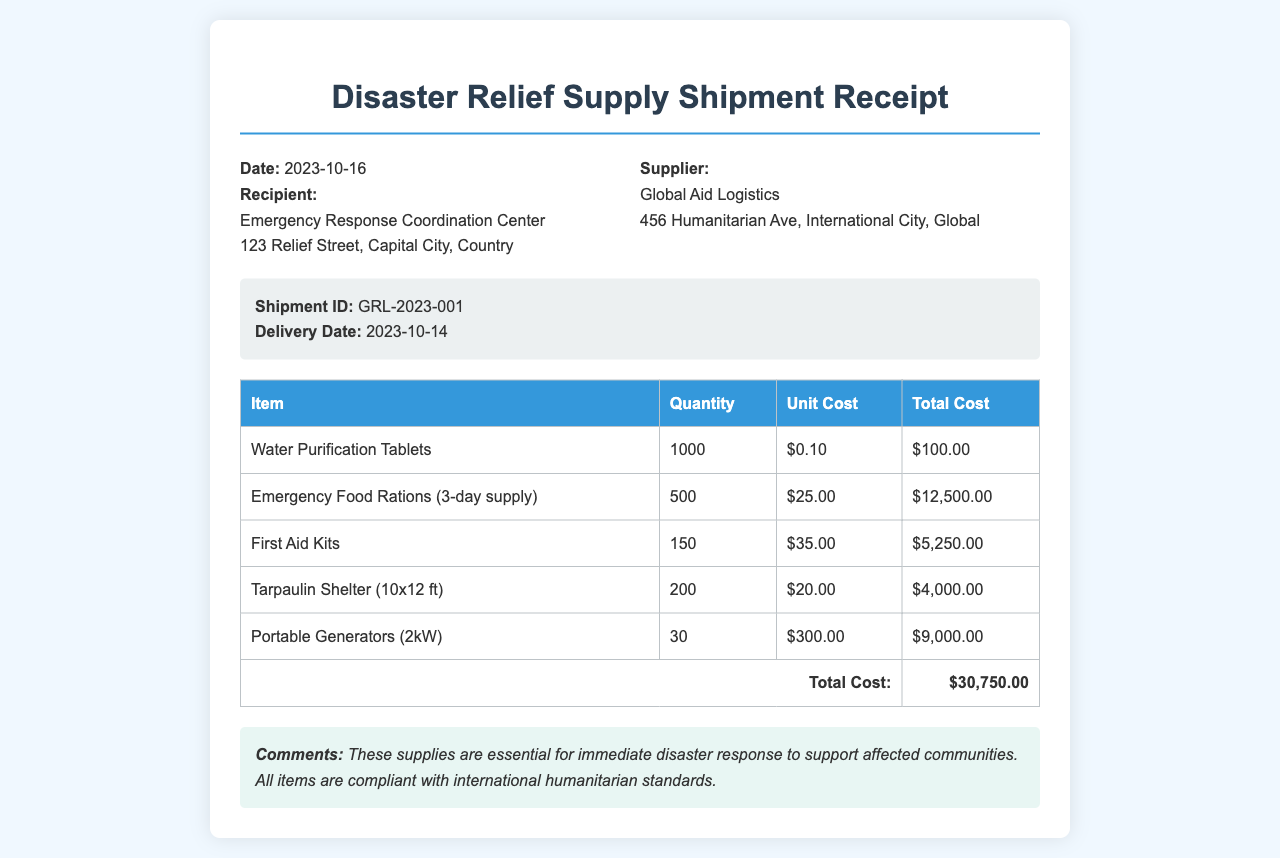What is the date of the receipt? The date of the receipt is stated clearly in the header section as 2023-10-16.
Answer: 2023-10-16 What is the total cost of the shipment? The total cost is provided in the footer of the table, summing up all item costs, which is $30,750.00.
Answer: $30,750.00 How many Emergency Food Rations were delivered? The quantity of Emergency Food Rations is listed in the table under its respective item, which is 500.
Answer: 500 Who is the recipient of the shipment? The recipient's name is mentioned in the header section as Emergency Response Coordination Center.
Answer: Emergency Response Coordination Center What is the unit cost of a Portable Generator? The unit cost for a Portable Generator is listed in the table and is $300.00.
Answer: $300.00 What is the delivery date of the shipment? The delivery date of the shipment is explicitly mentioned in the shipment details as 2023-10-14.
Answer: 2023-10-14 How many First Aid Kits were included in the shipment? The number of First Aid Kits delivered is provided in the shipment details table, which states 150.
Answer: 150 What kind of supplies does the comment section describe? The comments section highlights that the supplies are essential for immediate disaster response.
Answer: Immediate disaster response 